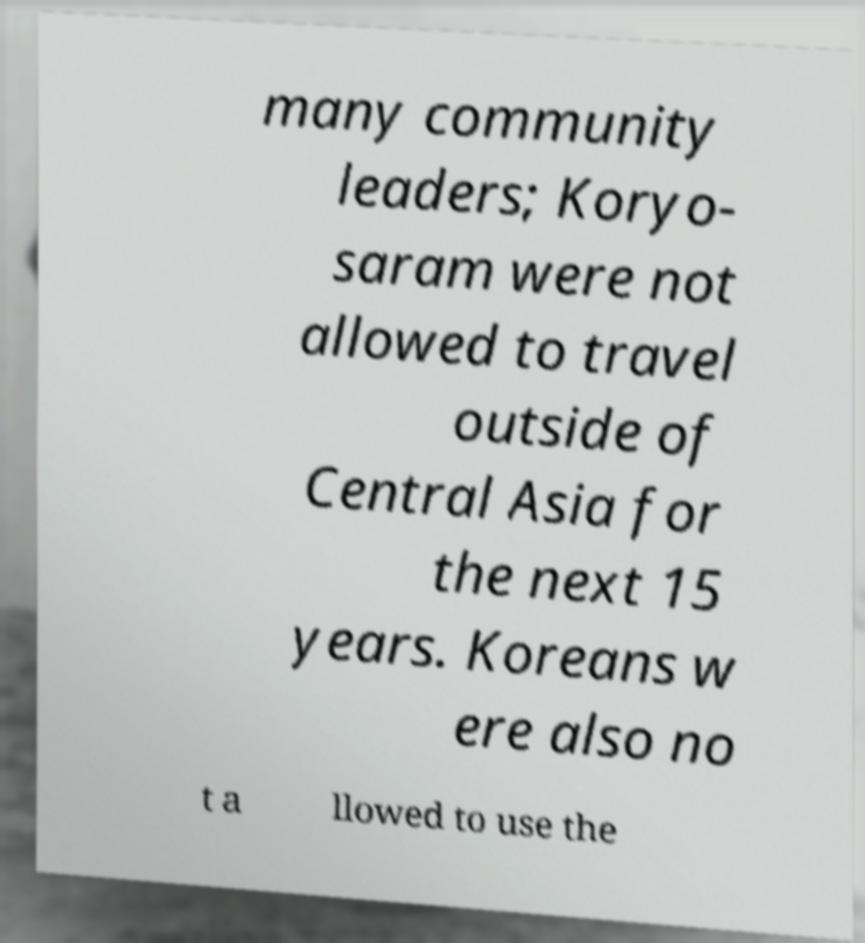Please read and relay the text visible in this image. What does it say? many community leaders; Koryo- saram were not allowed to travel outside of Central Asia for the next 15 years. Koreans w ere also no t a llowed to use the 